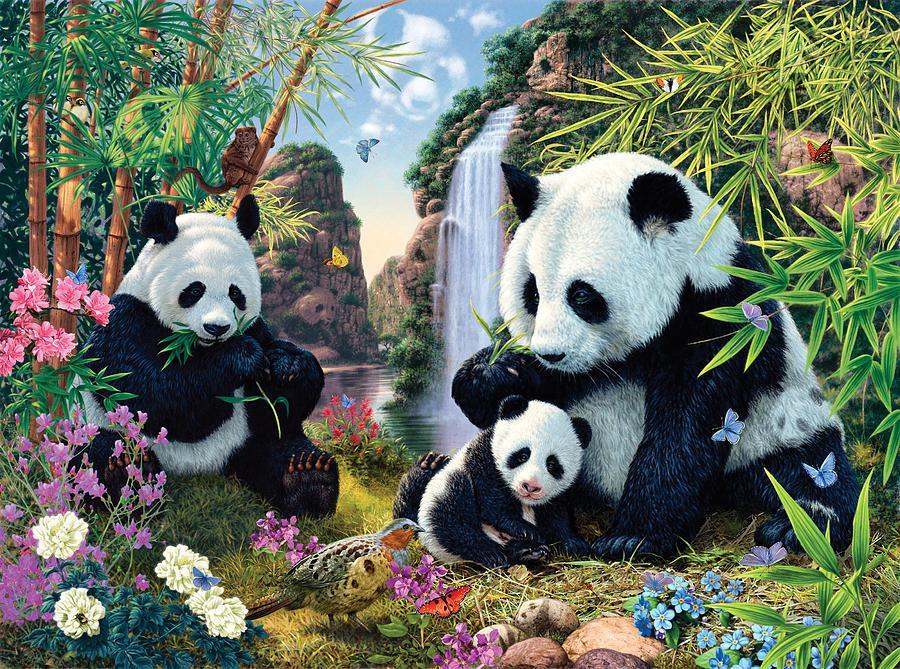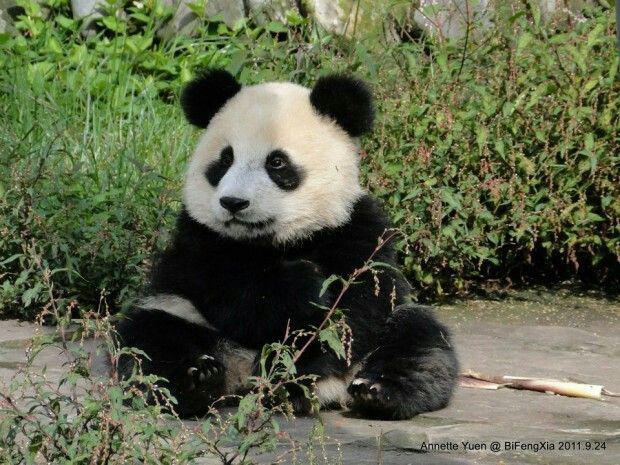The first image is the image on the left, the second image is the image on the right. Considering the images on both sides, is "Some pandas are in the snow." valid? Answer yes or no. No. The first image is the image on the left, the second image is the image on the right. Examine the images to the left and right. Is the description "There is at least one image where a single bear is animal is sitting alone." accurate? Answer yes or no. Yes. 